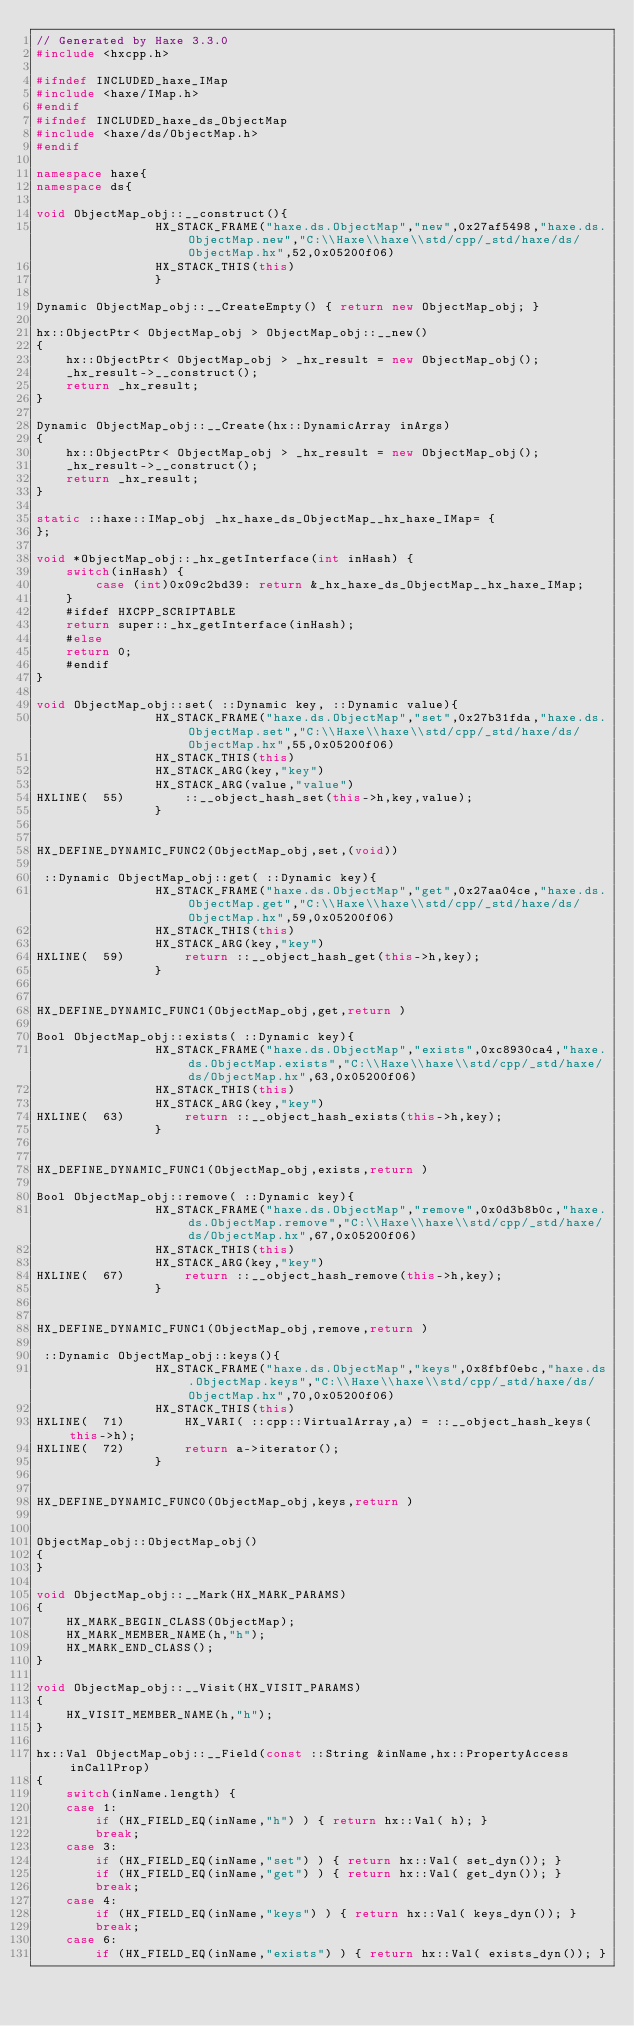<code> <loc_0><loc_0><loc_500><loc_500><_C++_>// Generated by Haxe 3.3.0
#include <hxcpp.h>

#ifndef INCLUDED_haxe_IMap
#include <haxe/IMap.h>
#endif
#ifndef INCLUDED_haxe_ds_ObjectMap
#include <haxe/ds/ObjectMap.h>
#endif

namespace haxe{
namespace ds{

void ObjectMap_obj::__construct(){
            	HX_STACK_FRAME("haxe.ds.ObjectMap","new",0x27af5498,"haxe.ds.ObjectMap.new","C:\\Haxe\\haxe\\std/cpp/_std/haxe/ds/ObjectMap.hx",52,0x05200f06)
            	HX_STACK_THIS(this)
            	}

Dynamic ObjectMap_obj::__CreateEmpty() { return new ObjectMap_obj; }

hx::ObjectPtr< ObjectMap_obj > ObjectMap_obj::__new()
{
	hx::ObjectPtr< ObjectMap_obj > _hx_result = new ObjectMap_obj();
	_hx_result->__construct();
	return _hx_result;
}

Dynamic ObjectMap_obj::__Create(hx::DynamicArray inArgs)
{
	hx::ObjectPtr< ObjectMap_obj > _hx_result = new ObjectMap_obj();
	_hx_result->__construct();
	return _hx_result;
}

static ::haxe::IMap_obj _hx_haxe_ds_ObjectMap__hx_haxe_IMap= {
};

void *ObjectMap_obj::_hx_getInterface(int inHash) {
	switch(inHash) {
		case (int)0x09c2bd39: return &_hx_haxe_ds_ObjectMap__hx_haxe_IMap;
	}
	#ifdef HXCPP_SCRIPTABLE
	return super::_hx_getInterface(inHash);
	#else
	return 0;
	#endif
}

void ObjectMap_obj::set( ::Dynamic key, ::Dynamic value){
            	HX_STACK_FRAME("haxe.ds.ObjectMap","set",0x27b31fda,"haxe.ds.ObjectMap.set","C:\\Haxe\\haxe\\std/cpp/_std/haxe/ds/ObjectMap.hx",55,0x05200f06)
            	HX_STACK_THIS(this)
            	HX_STACK_ARG(key,"key")
            	HX_STACK_ARG(value,"value")
HXLINE(  55)		::__object_hash_set(this->h,key,value);
            	}


HX_DEFINE_DYNAMIC_FUNC2(ObjectMap_obj,set,(void))

 ::Dynamic ObjectMap_obj::get( ::Dynamic key){
            	HX_STACK_FRAME("haxe.ds.ObjectMap","get",0x27aa04ce,"haxe.ds.ObjectMap.get","C:\\Haxe\\haxe\\std/cpp/_std/haxe/ds/ObjectMap.hx",59,0x05200f06)
            	HX_STACK_THIS(this)
            	HX_STACK_ARG(key,"key")
HXLINE(  59)		return ::__object_hash_get(this->h,key);
            	}


HX_DEFINE_DYNAMIC_FUNC1(ObjectMap_obj,get,return )

Bool ObjectMap_obj::exists( ::Dynamic key){
            	HX_STACK_FRAME("haxe.ds.ObjectMap","exists",0xc8930ca4,"haxe.ds.ObjectMap.exists","C:\\Haxe\\haxe\\std/cpp/_std/haxe/ds/ObjectMap.hx",63,0x05200f06)
            	HX_STACK_THIS(this)
            	HX_STACK_ARG(key,"key")
HXLINE(  63)		return ::__object_hash_exists(this->h,key);
            	}


HX_DEFINE_DYNAMIC_FUNC1(ObjectMap_obj,exists,return )

Bool ObjectMap_obj::remove( ::Dynamic key){
            	HX_STACK_FRAME("haxe.ds.ObjectMap","remove",0x0d3b8b0c,"haxe.ds.ObjectMap.remove","C:\\Haxe\\haxe\\std/cpp/_std/haxe/ds/ObjectMap.hx",67,0x05200f06)
            	HX_STACK_THIS(this)
            	HX_STACK_ARG(key,"key")
HXLINE(  67)		return ::__object_hash_remove(this->h,key);
            	}


HX_DEFINE_DYNAMIC_FUNC1(ObjectMap_obj,remove,return )

 ::Dynamic ObjectMap_obj::keys(){
            	HX_STACK_FRAME("haxe.ds.ObjectMap","keys",0x8fbf0ebc,"haxe.ds.ObjectMap.keys","C:\\Haxe\\haxe\\std/cpp/_std/haxe/ds/ObjectMap.hx",70,0x05200f06)
            	HX_STACK_THIS(this)
HXLINE(  71)		HX_VARI( ::cpp::VirtualArray,a) = ::__object_hash_keys(this->h);
HXLINE(  72)		return a->iterator();
            	}


HX_DEFINE_DYNAMIC_FUNC0(ObjectMap_obj,keys,return )


ObjectMap_obj::ObjectMap_obj()
{
}

void ObjectMap_obj::__Mark(HX_MARK_PARAMS)
{
	HX_MARK_BEGIN_CLASS(ObjectMap);
	HX_MARK_MEMBER_NAME(h,"h");
	HX_MARK_END_CLASS();
}

void ObjectMap_obj::__Visit(HX_VISIT_PARAMS)
{
	HX_VISIT_MEMBER_NAME(h,"h");
}

hx::Val ObjectMap_obj::__Field(const ::String &inName,hx::PropertyAccess inCallProp)
{
	switch(inName.length) {
	case 1:
		if (HX_FIELD_EQ(inName,"h") ) { return hx::Val( h); }
		break;
	case 3:
		if (HX_FIELD_EQ(inName,"set") ) { return hx::Val( set_dyn()); }
		if (HX_FIELD_EQ(inName,"get") ) { return hx::Val( get_dyn()); }
		break;
	case 4:
		if (HX_FIELD_EQ(inName,"keys") ) { return hx::Val( keys_dyn()); }
		break;
	case 6:
		if (HX_FIELD_EQ(inName,"exists") ) { return hx::Val( exists_dyn()); }</code> 